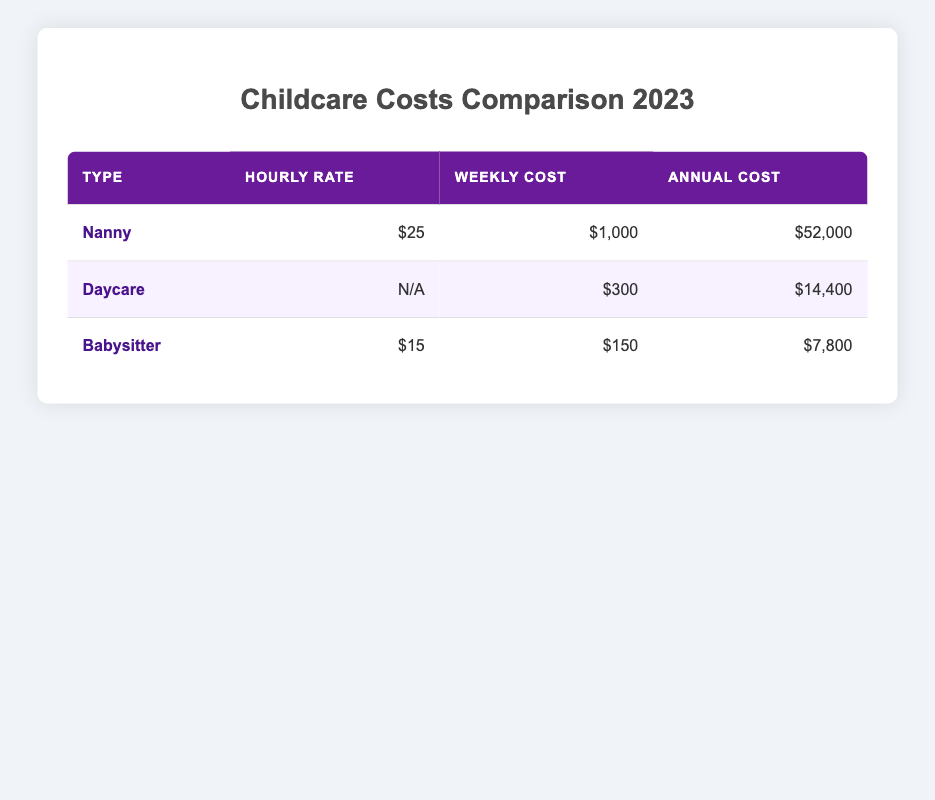What is the average hourly rate for a nanny? The table indicates that the average hourly rate for a nanny is listed as $25.
Answer: $25 What is the annual cost of hiring a daycare? According to the table, the annual cost for daycare is stated as $14,400.
Answer: $14,400 Is the weekly cost for a babysitter higher than that of a nanny? The weekly cost for a babysitter is $150, while the weekly cost for a nanny is $1,000, which shows that the babysitter's cost is lower.
Answer: No If I hire a nanny for 40 hours a week, how much will I spend in a month? The weekly cost for a nanny is $1,000, meaning in a month (4 weeks), the total cost will be $1,000 multiplied by 4, which is $4,000.
Answer: $4,000 How much cheaper is a babysitter compared to a daycare on an annual basis? The annual cost of a daycare is $14,400 while a babysitter costs $7,800 annually. The difference is calculated as $14,400 minus $7,800, which equals $6,600.
Answer: $6,600 What is the total annual cost of hiring a nanny and a babysitter combined? The annual cost for a nanny is $52,000 and for a babysitter is $7,800. Adding these two amounts gives $52,000 plus $7,800, resulting in a total of $59,800.
Answer: $59,800 Is the average hourly rate for a babysitter less than that of a nanny? The average hourly rate for a babysitter is $15, while the average hourly rate for a nanny is $25, which confirms that the babysitter's rate is indeed lower.
Answer: Yes How much does it cost to hire a babysitter for 10 hours a week annually? The weekly cost for a babysitter at 10 hours is $150. Over a year (52 weeks), this totals to $150 multiplied by 52, equaling $7,800.
Answer: $7,800 What is the most expensive childcare option based on annual costs? By comparing the annual costs, the nanny's cost is $52,000, which is higher than both daycare and babysitter costs. Therefore, the nanny represents the most expensive option.
Answer: Nanny 